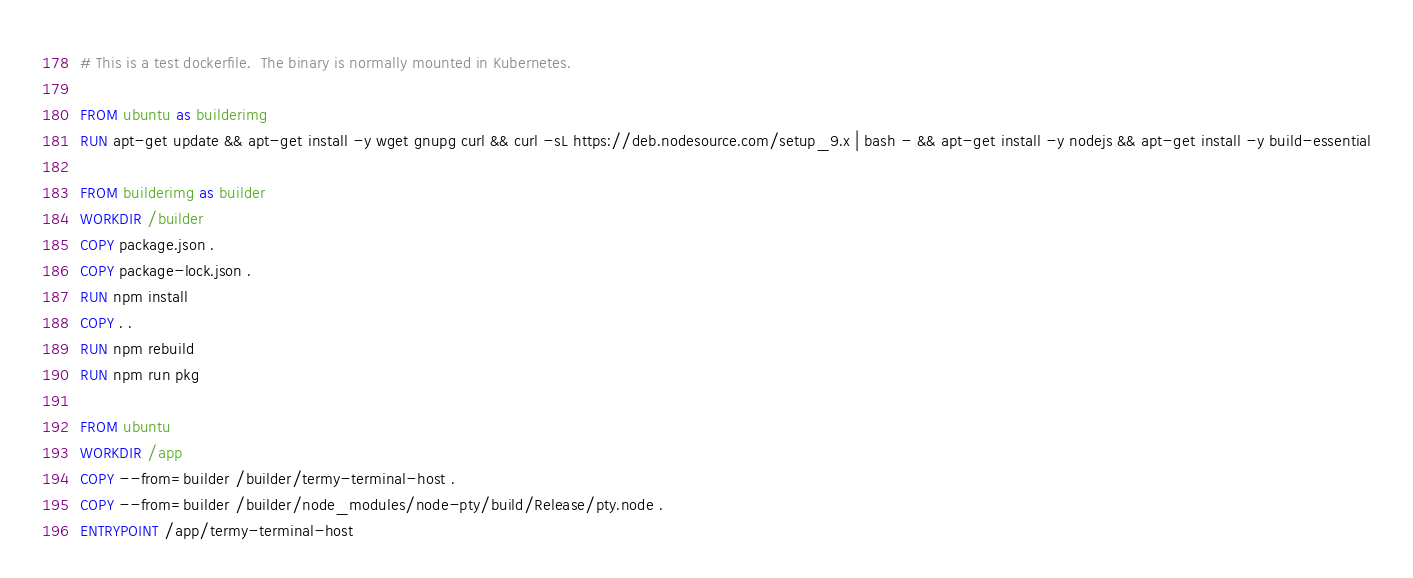Convert code to text. <code><loc_0><loc_0><loc_500><loc_500><_Dockerfile_># This is a test dockerfile.  The binary is normally mounted in Kubernetes.

FROM ubuntu as builderimg
RUN apt-get update && apt-get install -y wget gnupg curl && curl -sL https://deb.nodesource.com/setup_9.x | bash - && apt-get install -y nodejs && apt-get install -y build-essential

FROM builderimg as builder
WORKDIR /builder
COPY package.json .
COPY package-lock.json .
RUN npm install
COPY . .
RUN npm rebuild
RUN npm run pkg

FROM ubuntu
WORKDIR /app
COPY --from=builder /builder/termy-terminal-host .
COPY --from=builder /builder/node_modules/node-pty/build/Release/pty.node .
ENTRYPOINT /app/termy-terminal-host</code> 